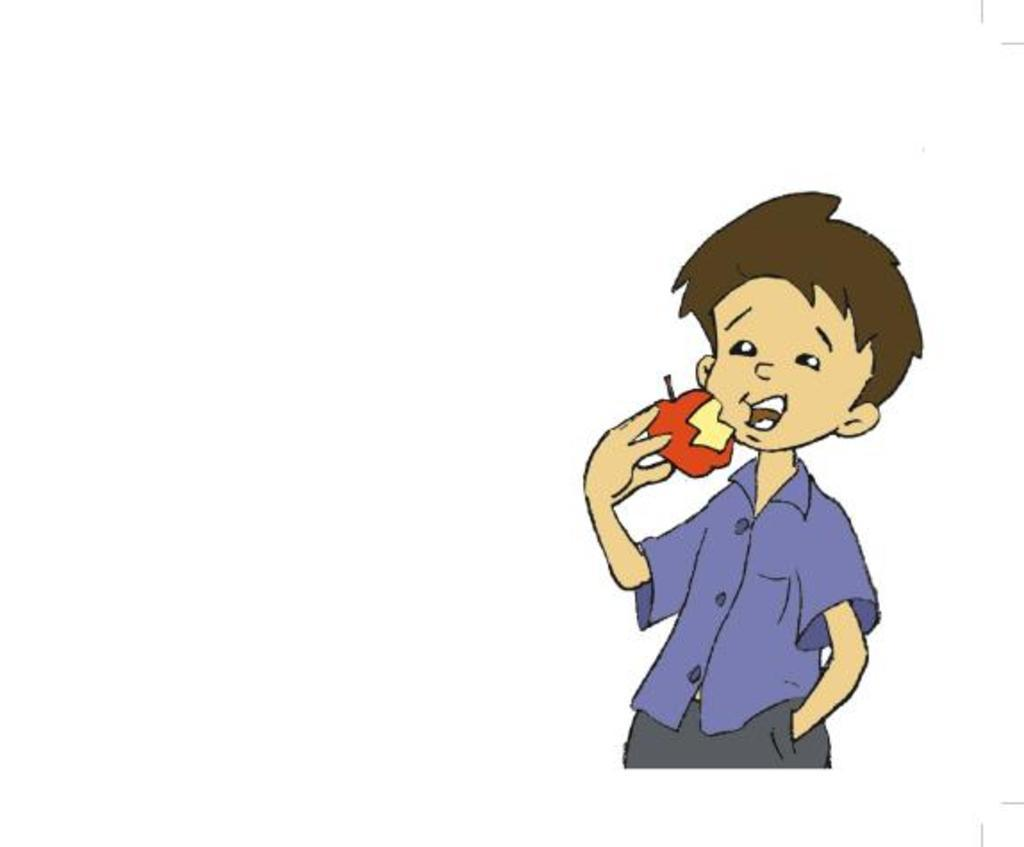What is the main subject of the art piece in the image? There is an art piece in the image, and it depicts a boy. What is the boy doing in the art piece? The boy is depicted as eating an apple in the art piece. What color is the background of the art piece? The background of the art piece is white. What type of copper wire is wrapped around the boy's arm in the image? There is no copper wire or any other wire present in the image; the boy is simply depicted as eating an apple. 